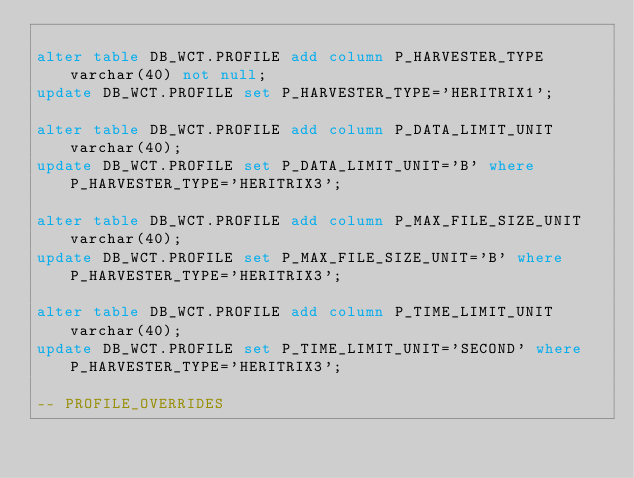Convert code to text. <code><loc_0><loc_0><loc_500><loc_500><_SQL_>
alter table DB_WCT.PROFILE add column P_HARVESTER_TYPE varchar(40) not null;
update DB_WCT.PROFILE set P_HARVESTER_TYPE='HERITRIX1';

alter table DB_WCT.PROFILE add column P_DATA_LIMIT_UNIT varchar(40);
update DB_WCT.PROFILE set P_DATA_LIMIT_UNIT='B' where P_HARVESTER_TYPE='HERITRIX3';

alter table DB_WCT.PROFILE add column P_MAX_FILE_SIZE_UNIT varchar(40);
update DB_WCT.PROFILE set P_MAX_FILE_SIZE_UNIT='B' where P_HARVESTER_TYPE='HERITRIX3';

alter table DB_WCT.PROFILE add column P_TIME_LIMIT_UNIT varchar(40);
update DB_WCT.PROFILE set P_TIME_LIMIT_UNIT='SECOND' where P_HARVESTER_TYPE='HERITRIX3';

-- PROFILE_OVERRIDES
</code> 